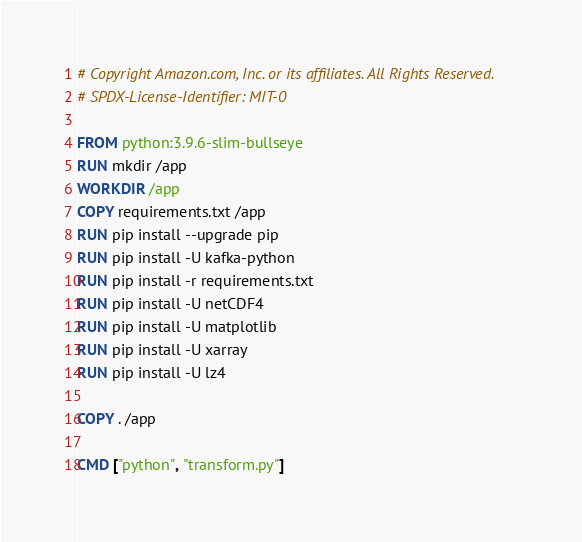Convert code to text. <code><loc_0><loc_0><loc_500><loc_500><_Dockerfile_># Copyright Amazon.com, Inc. or its affiliates. All Rights Reserved.
# SPDX-License-Identifier: MIT-0

FROM python:3.9.6-slim-bullseye
RUN mkdir /app
WORKDIR /app
COPY requirements.txt /app
RUN pip install --upgrade pip
RUN pip install -U kafka-python
RUN pip install -r requirements.txt
RUN pip install -U netCDF4
RUN pip install -U matplotlib
RUN pip install -U xarray
RUN pip install -U lz4

COPY . /app

CMD ["python", "transform.py"]</code> 